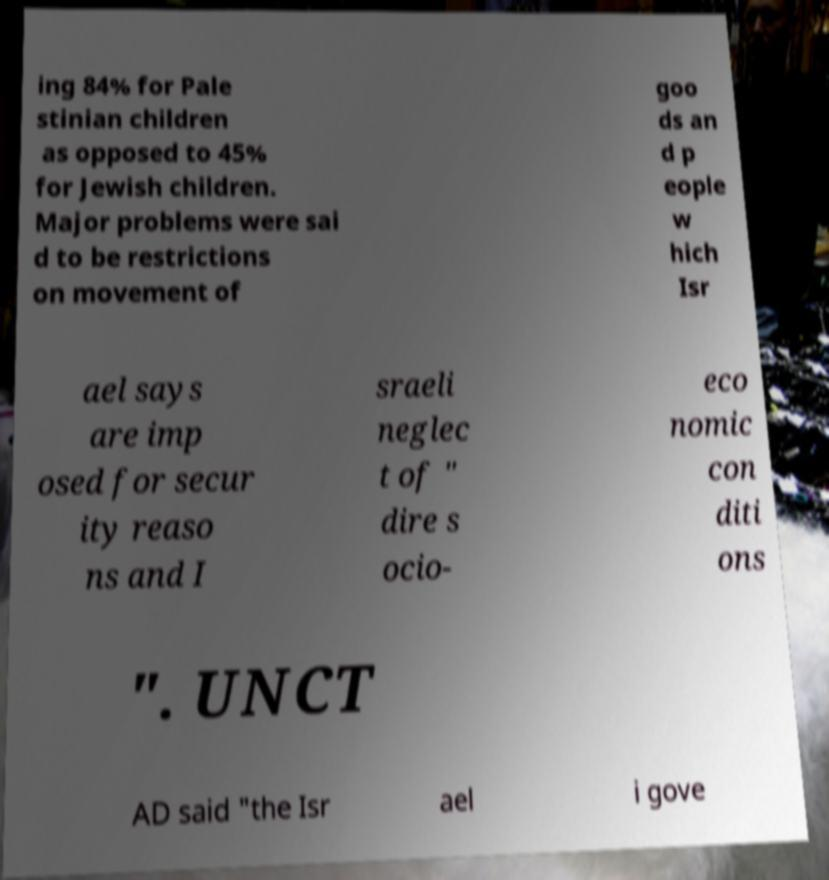I need the written content from this picture converted into text. Can you do that? ing 84% for Pale stinian children as opposed to 45% for Jewish children. Major problems were sai d to be restrictions on movement of goo ds an d p eople w hich Isr ael says are imp osed for secur ity reaso ns and I sraeli neglec t of " dire s ocio- eco nomic con diti ons ". UNCT AD said "the Isr ael i gove 